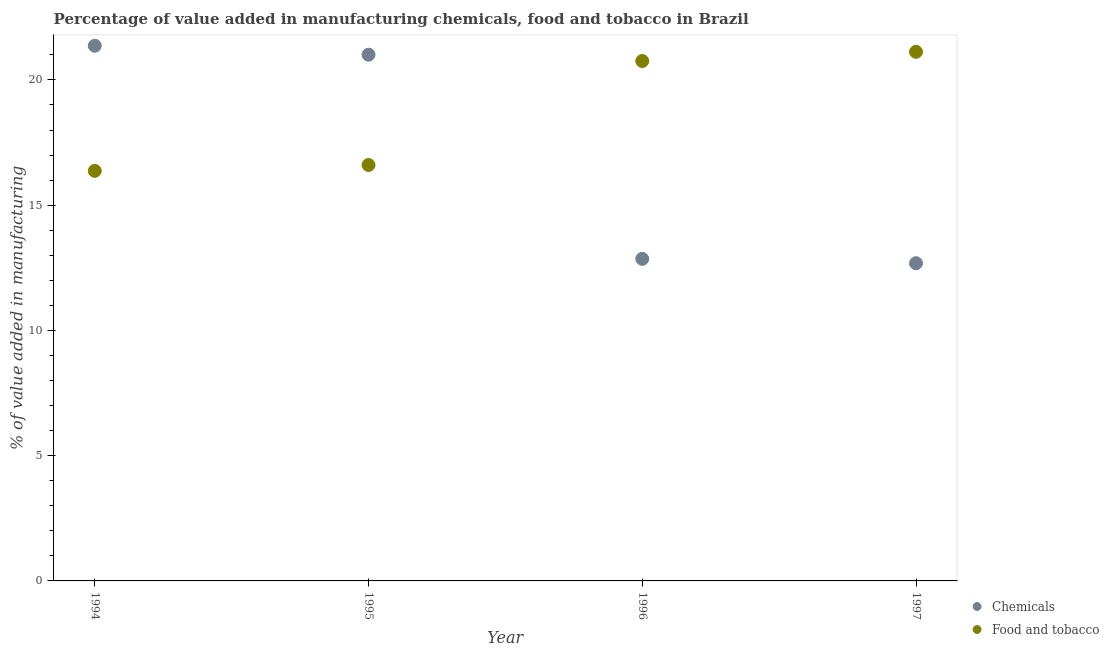How many different coloured dotlines are there?
Keep it short and to the point. 2. Is the number of dotlines equal to the number of legend labels?
Offer a very short reply. Yes. What is the value added by  manufacturing chemicals in 1995?
Make the answer very short. 21.01. Across all years, what is the maximum value added by  manufacturing chemicals?
Provide a succinct answer. 21.36. Across all years, what is the minimum value added by  manufacturing chemicals?
Keep it short and to the point. 12.68. In which year was the value added by  manufacturing chemicals minimum?
Your response must be concise. 1997. What is the total value added by  manufacturing chemicals in the graph?
Your answer should be compact. 67.91. What is the difference between the value added by  manufacturing chemicals in 1994 and that in 1997?
Offer a terse response. 8.68. What is the difference between the value added by manufacturing food and tobacco in 1994 and the value added by  manufacturing chemicals in 1995?
Provide a short and direct response. -4.64. What is the average value added by manufacturing food and tobacco per year?
Provide a succinct answer. 18.71. In the year 1995, what is the difference between the value added by manufacturing food and tobacco and value added by  manufacturing chemicals?
Your response must be concise. -4.4. What is the ratio of the value added by manufacturing food and tobacco in 1994 to that in 1995?
Provide a succinct answer. 0.99. What is the difference between the highest and the second highest value added by  manufacturing chemicals?
Your answer should be very brief. 0.36. What is the difference between the highest and the lowest value added by manufacturing food and tobacco?
Keep it short and to the point. 4.75. Is the sum of the value added by manufacturing food and tobacco in 1994 and 1996 greater than the maximum value added by  manufacturing chemicals across all years?
Your response must be concise. Yes. Is the value added by  manufacturing chemicals strictly greater than the value added by manufacturing food and tobacco over the years?
Give a very brief answer. No. How many dotlines are there?
Ensure brevity in your answer.  2. What is the difference between two consecutive major ticks on the Y-axis?
Give a very brief answer. 5. Are the values on the major ticks of Y-axis written in scientific E-notation?
Make the answer very short. No. How many legend labels are there?
Offer a terse response. 2. What is the title of the graph?
Offer a very short reply. Percentage of value added in manufacturing chemicals, food and tobacco in Brazil. Does "Lower secondary education" appear as one of the legend labels in the graph?
Offer a terse response. No. What is the label or title of the X-axis?
Give a very brief answer. Year. What is the label or title of the Y-axis?
Offer a terse response. % of value added in manufacturing. What is the % of value added in manufacturing of Chemicals in 1994?
Your response must be concise. 21.36. What is the % of value added in manufacturing of Food and tobacco in 1994?
Give a very brief answer. 16.37. What is the % of value added in manufacturing in Chemicals in 1995?
Give a very brief answer. 21.01. What is the % of value added in manufacturing of Food and tobacco in 1995?
Offer a terse response. 16.6. What is the % of value added in manufacturing in Chemicals in 1996?
Your answer should be compact. 12.86. What is the % of value added in manufacturing in Food and tobacco in 1996?
Give a very brief answer. 20.76. What is the % of value added in manufacturing of Chemicals in 1997?
Ensure brevity in your answer.  12.68. What is the % of value added in manufacturing in Food and tobacco in 1997?
Provide a short and direct response. 21.12. Across all years, what is the maximum % of value added in manufacturing in Chemicals?
Keep it short and to the point. 21.36. Across all years, what is the maximum % of value added in manufacturing of Food and tobacco?
Provide a succinct answer. 21.12. Across all years, what is the minimum % of value added in manufacturing of Chemicals?
Your answer should be compact. 12.68. Across all years, what is the minimum % of value added in manufacturing in Food and tobacco?
Make the answer very short. 16.37. What is the total % of value added in manufacturing of Chemicals in the graph?
Provide a short and direct response. 67.91. What is the total % of value added in manufacturing in Food and tobacco in the graph?
Ensure brevity in your answer.  74.85. What is the difference between the % of value added in manufacturing in Chemicals in 1994 and that in 1995?
Give a very brief answer. 0.36. What is the difference between the % of value added in manufacturing in Food and tobacco in 1994 and that in 1995?
Make the answer very short. -0.23. What is the difference between the % of value added in manufacturing in Chemicals in 1994 and that in 1996?
Your answer should be compact. 8.51. What is the difference between the % of value added in manufacturing of Food and tobacco in 1994 and that in 1996?
Make the answer very short. -4.39. What is the difference between the % of value added in manufacturing of Chemicals in 1994 and that in 1997?
Provide a succinct answer. 8.68. What is the difference between the % of value added in manufacturing of Food and tobacco in 1994 and that in 1997?
Offer a very short reply. -4.75. What is the difference between the % of value added in manufacturing of Chemicals in 1995 and that in 1996?
Give a very brief answer. 8.15. What is the difference between the % of value added in manufacturing in Food and tobacco in 1995 and that in 1996?
Offer a very short reply. -4.15. What is the difference between the % of value added in manufacturing in Chemicals in 1995 and that in 1997?
Your response must be concise. 8.33. What is the difference between the % of value added in manufacturing in Food and tobacco in 1995 and that in 1997?
Give a very brief answer. -4.52. What is the difference between the % of value added in manufacturing in Chemicals in 1996 and that in 1997?
Provide a short and direct response. 0.18. What is the difference between the % of value added in manufacturing in Food and tobacco in 1996 and that in 1997?
Offer a very short reply. -0.37. What is the difference between the % of value added in manufacturing of Chemicals in 1994 and the % of value added in manufacturing of Food and tobacco in 1995?
Make the answer very short. 4.76. What is the difference between the % of value added in manufacturing of Chemicals in 1994 and the % of value added in manufacturing of Food and tobacco in 1996?
Your answer should be very brief. 0.61. What is the difference between the % of value added in manufacturing of Chemicals in 1994 and the % of value added in manufacturing of Food and tobacco in 1997?
Ensure brevity in your answer.  0.24. What is the difference between the % of value added in manufacturing of Chemicals in 1995 and the % of value added in manufacturing of Food and tobacco in 1996?
Offer a very short reply. 0.25. What is the difference between the % of value added in manufacturing of Chemicals in 1995 and the % of value added in manufacturing of Food and tobacco in 1997?
Offer a very short reply. -0.12. What is the difference between the % of value added in manufacturing in Chemicals in 1996 and the % of value added in manufacturing in Food and tobacco in 1997?
Offer a very short reply. -8.27. What is the average % of value added in manufacturing of Chemicals per year?
Your answer should be very brief. 16.98. What is the average % of value added in manufacturing of Food and tobacco per year?
Your response must be concise. 18.71. In the year 1994, what is the difference between the % of value added in manufacturing of Chemicals and % of value added in manufacturing of Food and tobacco?
Your answer should be compact. 4.99. In the year 1995, what is the difference between the % of value added in manufacturing in Chemicals and % of value added in manufacturing in Food and tobacco?
Keep it short and to the point. 4.4. In the year 1996, what is the difference between the % of value added in manufacturing of Chemicals and % of value added in manufacturing of Food and tobacco?
Provide a succinct answer. -7.9. In the year 1997, what is the difference between the % of value added in manufacturing of Chemicals and % of value added in manufacturing of Food and tobacco?
Make the answer very short. -8.44. What is the ratio of the % of value added in manufacturing in Chemicals in 1994 to that in 1995?
Offer a terse response. 1.02. What is the ratio of the % of value added in manufacturing in Food and tobacco in 1994 to that in 1995?
Offer a terse response. 0.99. What is the ratio of the % of value added in manufacturing in Chemicals in 1994 to that in 1996?
Offer a very short reply. 1.66. What is the ratio of the % of value added in manufacturing in Food and tobacco in 1994 to that in 1996?
Ensure brevity in your answer.  0.79. What is the ratio of the % of value added in manufacturing of Chemicals in 1994 to that in 1997?
Offer a terse response. 1.68. What is the ratio of the % of value added in manufacturing of Food and tobacco in 1994 to that in 1997?
Offer a terse response. 0.78. What is the ratio of the % of value added in manufacturing of Chemicals in 1995 to that in 1996?
Give a very brief answer. 1.63. What is the ratio of the % of value added in manufacturing of Chemicals in 1995 to that in 1997?
Ensure brevity in your answer.  1.66. What is the ratio of the % of value added in manufacturing of Food and tobacco in 1995 to that in 1997?
Provide a short and direct response. 0.79. What is the ratio of the % of value added in manufacturing of Chemicals in 1996 to that in 1997?
Make the answer very short. 1.01. What is the ratio of the % of value added in manufacturing in Food and tobacco in 1996 to that in 1997?
Ensure brevity in your answer.  0.98. What is the difference between the highest and the second highest % of value added in manufacturing in Chemicals?
Make the answer very short. 0.36. What is the difference between the highest and the second highest % of value added in manufacturing in Food and tobacco?
Offer a terse response. 0.37. What is the difference between the highest and the lowest % of value added in manufacturing of Chemicals?
Your response must be concise. 8.68. What is the difference between the highest and the lowest % of value added in manufacturing in Food and tobacco?
Offer a very short reply. 4.75. 